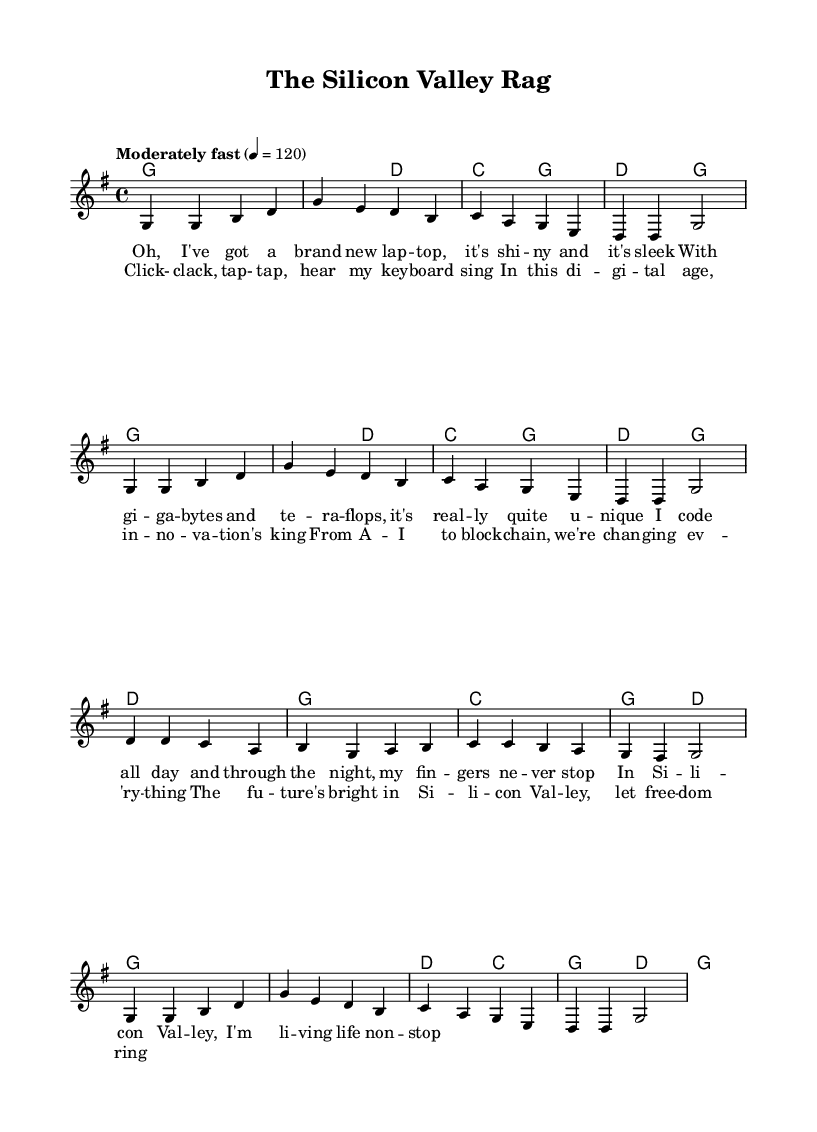What is the key signature of this music? The key signature is indicated by the number of sharps or flats at the beginning of the staff. In this case, there are no sharps or flats shown, which indicates the key of G major.
Answer: G major What is the time signature of this music? The time signature is located at the beginning of the staff, shown as two numbers, with the top number indicating beats per measure and the bottom indicating the note value for those beats. Here, it shows 4 over 4, meaning there are four beats per measure and the quarter note gets the beat.
Answer: 4/4 What is the tempo marking? The tempo is indicated in the score, typically shown above the staff. In this case, the indication reads "Moderately fast" with a tempo of 120 beats per minute, indicating the speed of the music.
Answer: Moderately fast, 120 How many measures are there in the melody? To determine the number of measures, count the segments divided by vertical lines (bar lines) in the melody section. Each set of notes between the lines represents one measure. After counting, there are 8 measures present in the melody part.
Answer: 8 What types of modern technology are mentioned in the lyrics? The lyrics mention specific modern technological terms such as "laptop," "gigabytes," and "teraflops," which reflect the theme of innovation and technology in the song.
Answer: Laptop, gigabytes, teraflops How does the structure of the song reflect typical folk music traits? Folk music often features repeated phrases or a simple structure with verses and a chorus that can be easily remembered. In this piece, the song has a clear verse followed by a chorus, aligning with folk music's usual patterns.
Answer: Verse/Chorus structure What is the main theme of this folk song? The main theme is derived from the lyrics, which focus on the experiences and innovations of life in Silicon Valley, integrating traditional folk song elements with modern topics such as technology and innovation.
Answer: Life in Silicon Valley and technology 